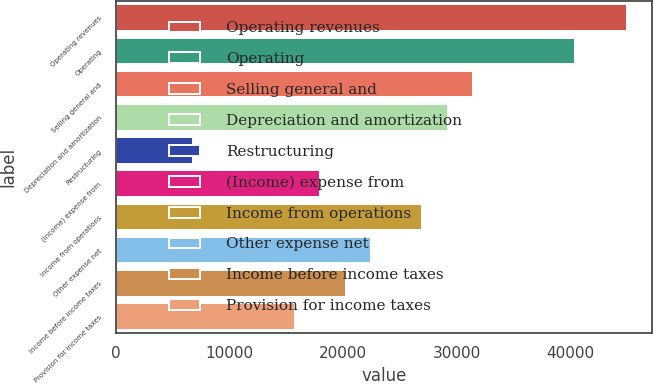Convert chart. <chart><loc_0><loc_0><loc_500><loc_500><bar_chart><fcel>Operating revenues<fcel>Operating<fcel>Selling general and<fcel>Depreciation and amortization<fcel>Restructuring<fcel>(Income) expense from<fcel>Income from operations<fcel>Other expense net<fcel>Income before income taxes<fcel>Provision for income taxes<nl><fcel>44979.8<fcel>40481.8<fcel>31485.9<fcel>29237<fcel>6747.15<fcel>17992<fcel>26988<fcel>22490<fcel>20241<fcel>15743.1<nl></chart> 